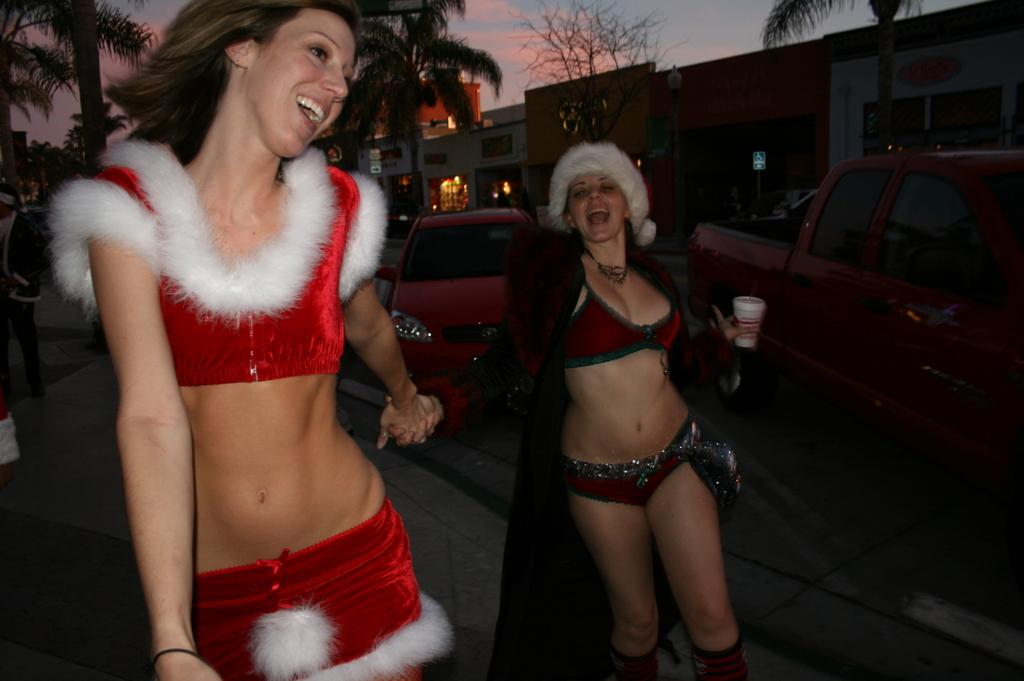How many people are in the image? There are two persons standing and smiling in the image. What can be seen on the road in the image? There are vehicles on the road in the image. What type of structures are visible in the image? There are buildings visible in the image. What is visible in the background of the image? Trees and the sky are visible in the background of the image. What type of doctor is present in the image? There is no doctor present in the image. Can you tell me how the image is being copied? The image is not being copied in the image itself; it is a static photograph. 